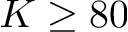<formula> <loc_0><loc_0><loc_500><loc_500>K \geq 8 0</formula> 